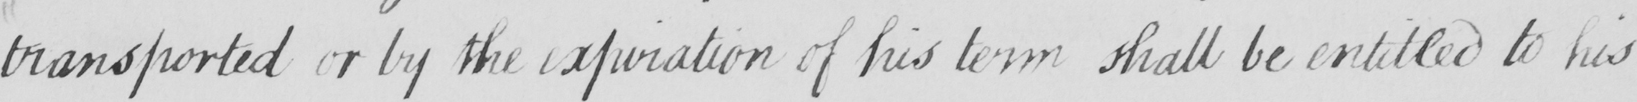Can you read and transcribe this handwriting? transported or by the expiration of his term shall be entitled to his 